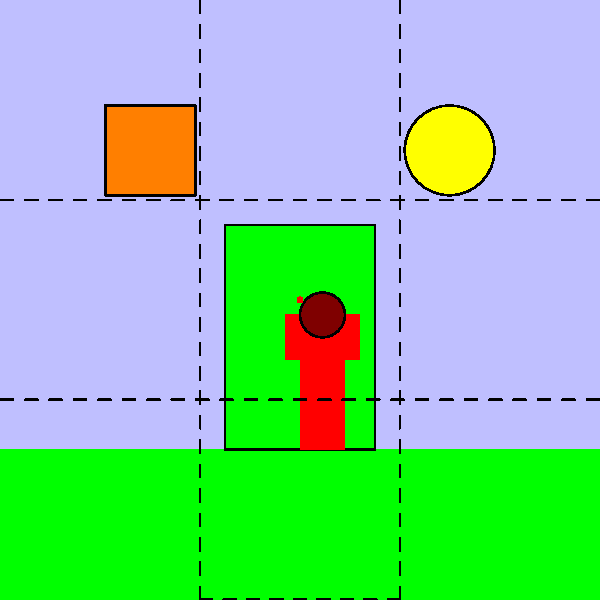In this composition inspired by Mario's adventures, which principle of design is most prominently demonstrated by the placement of elements along the intersection points of the dashed lines? To answer this question, let's analyze the composition step-by-step:

1. The dashed lines in the image represent a grid dividing the composition into thirds both horizontally and vertically. This is known as the "Rule of Thirds" grid.

2. The Rule of Thirds is a principle in art and design that suggests placing key elements along these lines or at their intersections to create a more balanced and interesting composition.

3. In this image, we can observe that:
   - The question block is placed near the top-left intersection point
   - The coin is positioned close to the top-right intersection point
   - Mario is situated near the bottom-left intersection point
   - The pipe is aligned with the bottom-right section of the grid

4. By placing these elements at or near the intersection points of the Rule of Thirds grid, the artist has created a balanced and visually appealing composition.

5. This arrangement demonstrates the principle of balance in design, specifically asymmetrical balance. The elements are not symmetrically arranged, but they are distributed in a way that creates visual equilibrium.

6. The Rule of Thirds is a technique used to achieve this balance and to create points of interest that guide the viewer's eye through the composition.

Therefore, the principle of design most prominently demonstrated by the placement of elements along the intersection points of the dashed lines is the Rule of Thirds, which is a method of creating balance and visual interest in a composition.
Answer: Rule of Thirds 